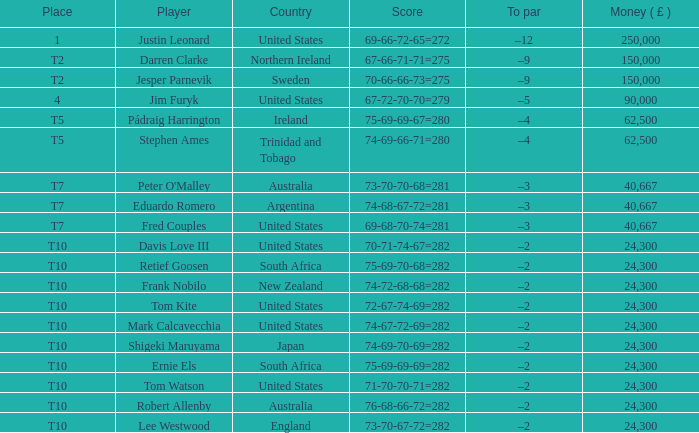Would you be able to parse every entry in this table? {'header': ['Place', 'Player', 'Country', 'Score', 'To par', 'Money ( £ )'], 'rows': [['1', 'Justin Leonard', 'United States', '69-66-72-65=272', '–12', '250,000'], ['T2', 'Darren Clarke', 'Northern Ireland', '67-66-71-71=275', '–9', '150,000'], ['T2', 'Jesper Parnevik', 'Sweden', '70-66-66-73=275', '–9', '150,000'], ['4', 'Jim Furyk', 'United States', '67-72-70-70=279', '–5', '90,000'], ['T5', 'Pádraig Harrington', 'Ireland', '75-69-69-67=280', '–4', '62,500'], ['T5', 'Stephen Ames', 'Trinidad and Tobago', '74-69-66-71=280', '–4', '62,500'], ['T7', "Peter O'Malley", 'Australia', '73-70-70-68=281', '–3', '40,667'], ['T7', 'Eduardo Romero', 'Argentina', '74-68-67-72=281', '–3', '40,667'], ['T7', 'Fred Couples', 'United States', '69-68-70-74=281', '–3', '40,667'], ['T10', 'Davis Love III', 'United States', '70-71-74-67=282', '–2', '24,300'], ['T10', 'Retief Goosen', 'South Africa', '75-69-70-68=282', '–2', '24,300'], ['T10', 'Frank Nobilo', 'New Zealand', '74-72-68-68=282', '–2', '24,300'], ['T10', 'Tom Kite', 'United States', '72-67-74-69=282', '–2', '24,300'], ['T10', 'Mark Calcavecchia', 'United States', '74-67-72-69=282', '–2', '24,300'], ['T10', 'Shigeki Maruyama', 'Japan', '74-69-70-69=282', '–2', '24,300'], ['T10', 'Ernie Els', 'South Africa', '75-69-69-69=282', '–2', '24,300'], ['T10', 'Tom Watson', 'United States', '71-70-70-71=282', '–2', '24,300'], ['T10', 'Robert Allenby', 'Australia', '76-68-66-72=282', '–2', '24,300'], ['T10', 'Lee Westwood', 'England', '73-70-67-72=282', '–2', '24,300']]} What is Lee Westwood's score? 73-70-67-72=282. 